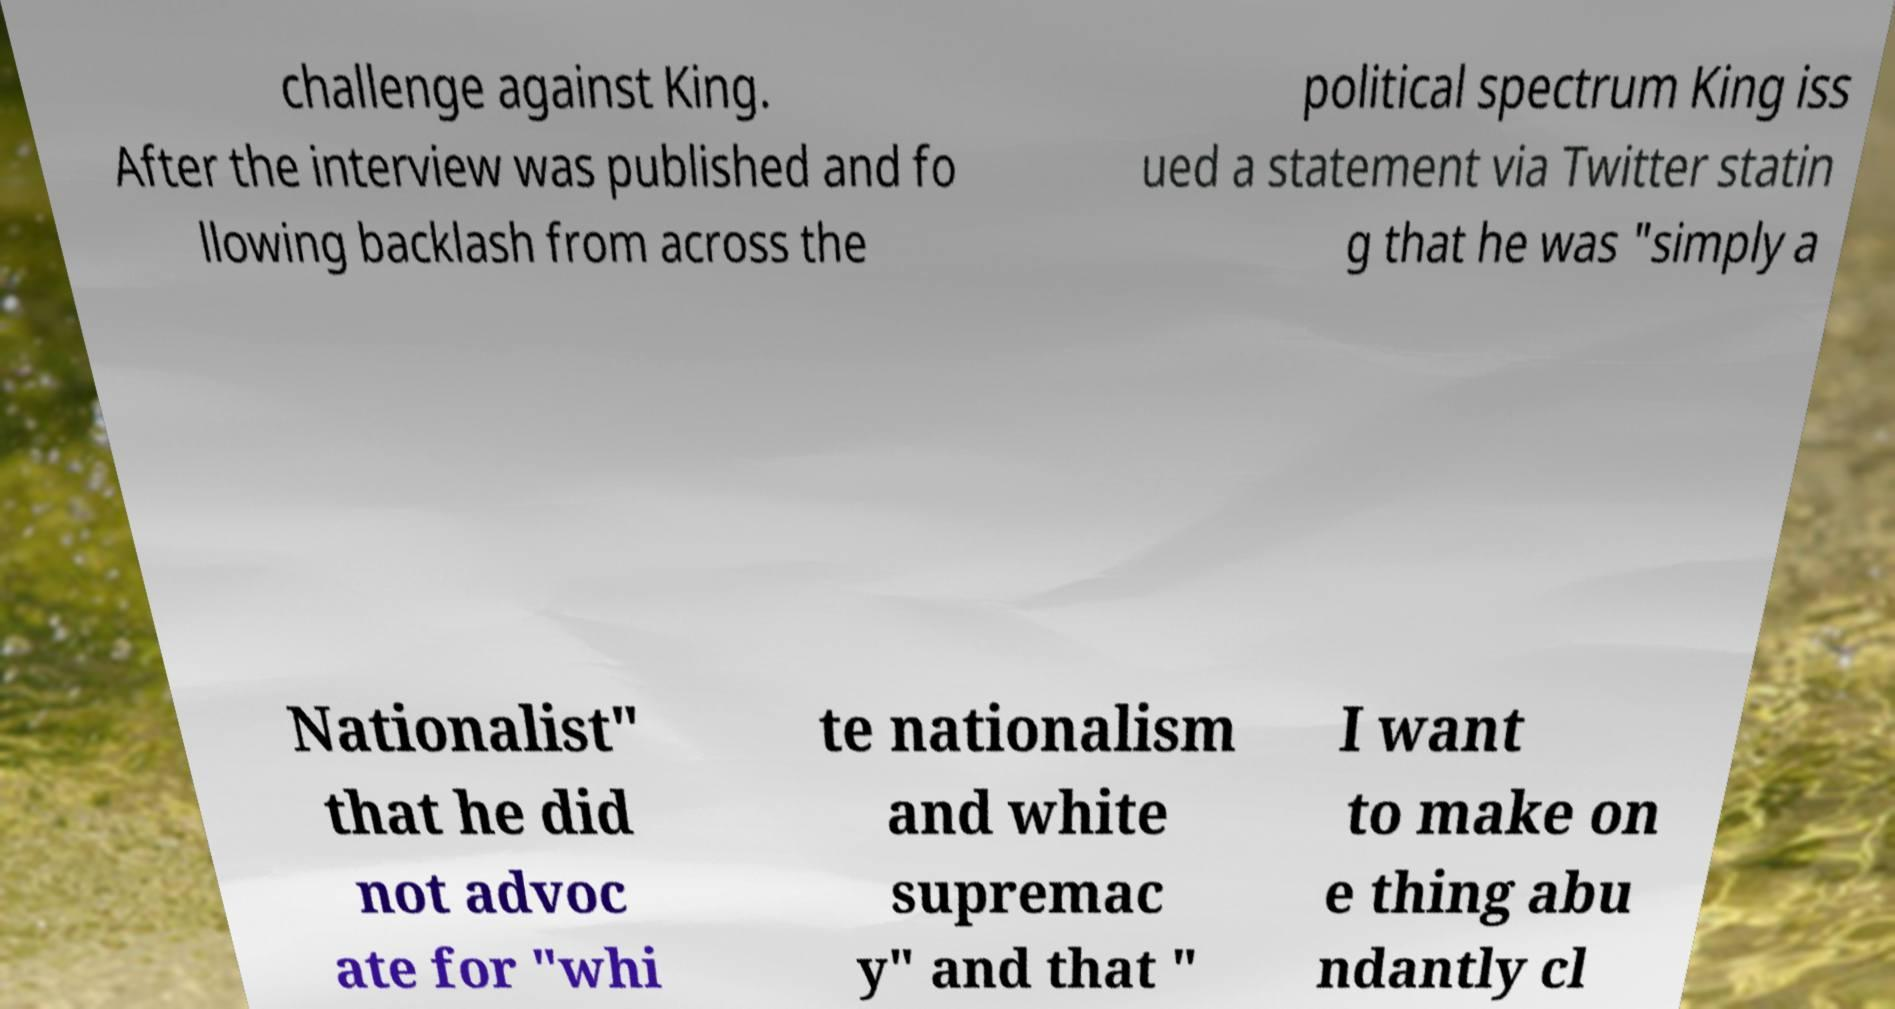For documentation purposes, I need the text within this image transcribed. Could you provide that? challenge against King. After the interview was published and fo llowing backlash from across the political spectrum King iss ued a statement via Twitter statin g that he was "simply a Nationalist" that he did not advoc ate for "whi te nationalism and white supremac y" and that " I want to make on e thing abu ndantly cl 